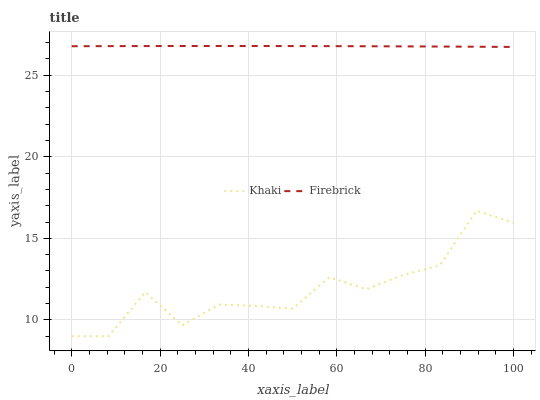Does Khaki have the minimum area under the curve?
Answer yes or no. Yes. Does Firebrick have the maximum area under the curve?
Answer yes or no. Yes. Does Khaki have the maximum area under the curve?
Answer yes or no. No. Is Firebrick the smoothest?
Answer yes or no. Yes. Is Khaki the roughest?
Answer yes or no. Yes. Is Khaki the smoothest?
Answer yes or no. No. Does Khaki have the lowest value?
Answer yes or no. Yes. Does Firebrick have the highest value?
Answer yes or no. Yes. Does Khaki have the highest value?
Answer yes or no. No. Is Khaki less than Firebrick?
Answer yes or no. Yes. Is Firebrick greater than Khaki?
Answer yes or no. Yes. Does Khaki intersect Firebrick?
Answer yes or no. No. 